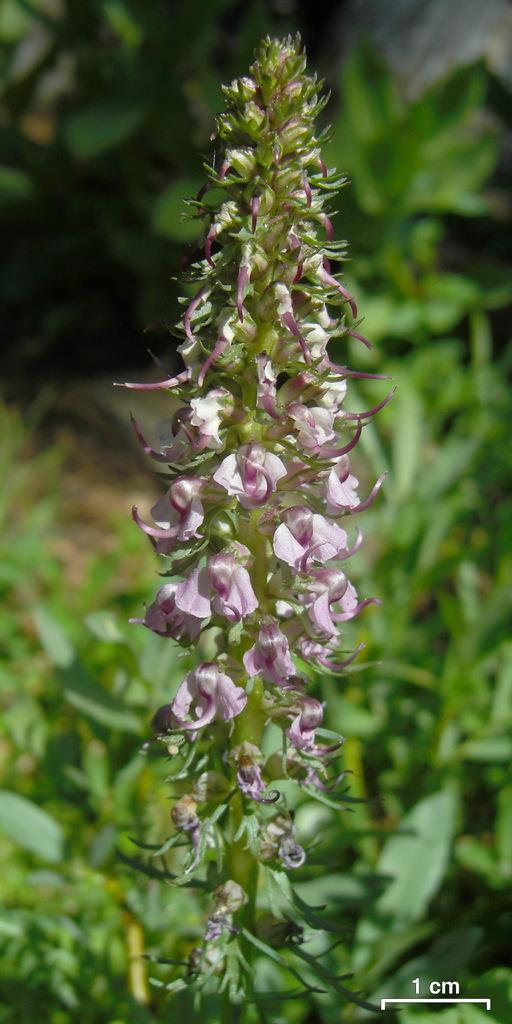What color are the flowers on the plant in the image? The flowers on the plant are light pink in color. What else can be seen in the image besides the flowers? There are plants visible in the background. Is there any text present in the image? Yes, there is a text in the bottom right corner of the image. What type of instrument is being played by the goose in the image? There is no goose or instrument present in the image. 